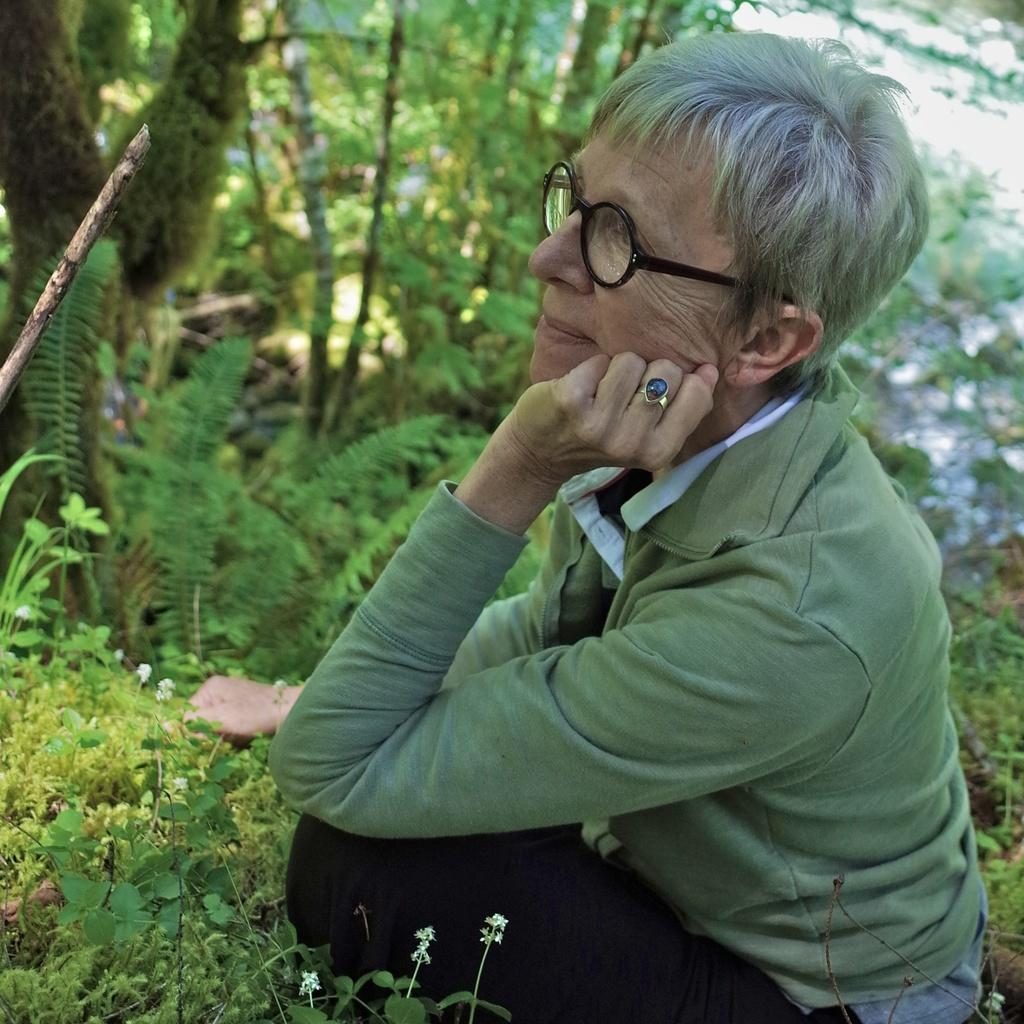Who or what is present in the image? There is a person in the image. What is the person doing in the image? The person is sitting on the grass. What can be seen in the background of the image? There are trees in the background of the image. Is the person in the image using a plough to grade the quicksand? There is no plough, grade, or quicksand present in the image. The person is simply sitting on the grass with trees in the background. 